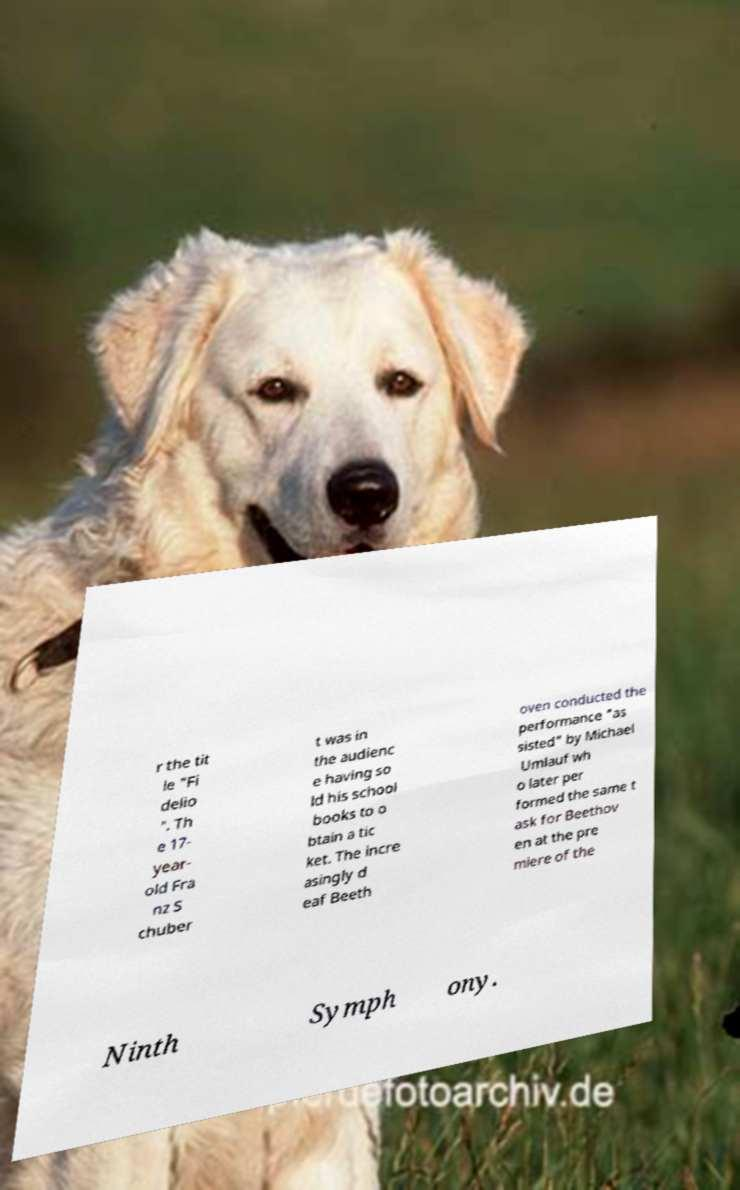What messages or text are displayed in this image? I need them in a readable, typed format. r the tit le "Fi delio ". Th e 17- year- old Fra nz S chuber t was in the audienc e having so ld his school books to o btain a tic ket. The incre asingly d eaf Beeth oven conducted the performance "as sisted" by Michael Umlauf wh o later per formed the same t ask for Beethov en at the pre miere of the Ninth Symph ony. 